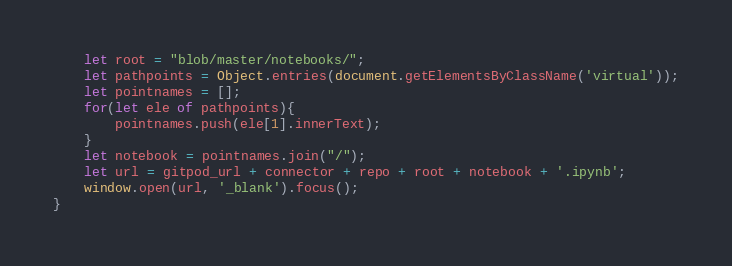Convert code to text. <code><loc_0><loc_0><loc_500><loc_500><_JavaScript_>    let root = "blob/master/notebooks/";
    let pathpoints = Object.entries(document.getElementsByClassName('virtual'));
    let pointnames = [];
    for(let ele of pathpoints){
        pointnames.push(ele[1].innerText);
    }
    let notebook = pointnames.join("/");
    let url = gitpod_url + connector + repo + root + notebook + '.ipynb';
    window.open(url, '_blank').focus();
}</code> 